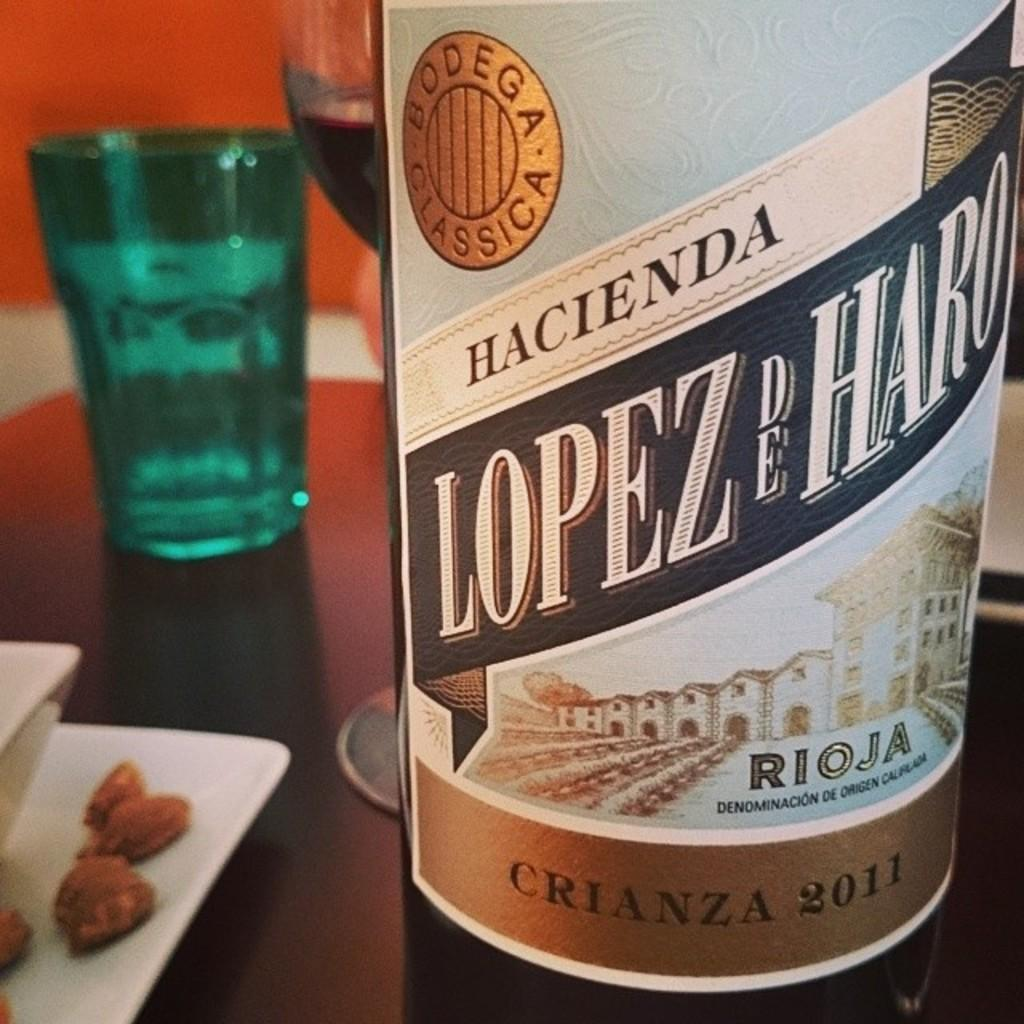<image>
Share a concise interpretation of the image provided. A bottle of Hacienda Lopez De Haro next to a glass on a table. 